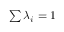<formula> <loc_0><loc_0><loc_500><loc_500>\sum \lambda _ { i } = 1</formula> 